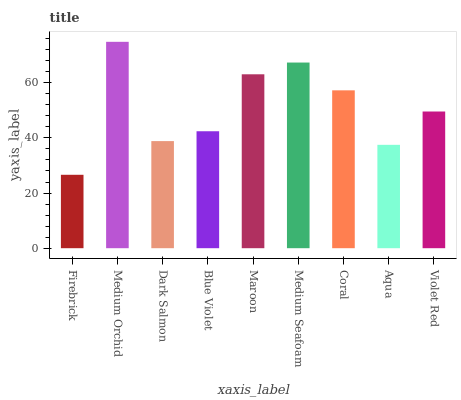Is Firebrick the minimum?
Answer yes or no. Yes. Is Medium Orchid the maximum?
Answer yes or no. Yes. Is Dark Salmon the minimum?
Answer yes or no. No. Is Dark Salmon the maximum?
Answer yes or no. No. Is Medium Orchid greater than Dark Salmon?
Answer yes or no. Yes. Is Dark Salmon less than Medium Orchid?
Answer yes or no. Yes. Is Dark Salmon greater than Medium Orchid?
Answer yes or no. No. Is Medium Orchid less than Dark Salmon?
Answer yes or no. No. Is Violet Red the high median?
Answer yes or no. Yes. Is Violet Red the low median?
Answer yes or no. Yes. Is Blue Violet the high median?
Answer yes or no. No. Is Dark Salmon the low median?
Answer yes or no. No. 